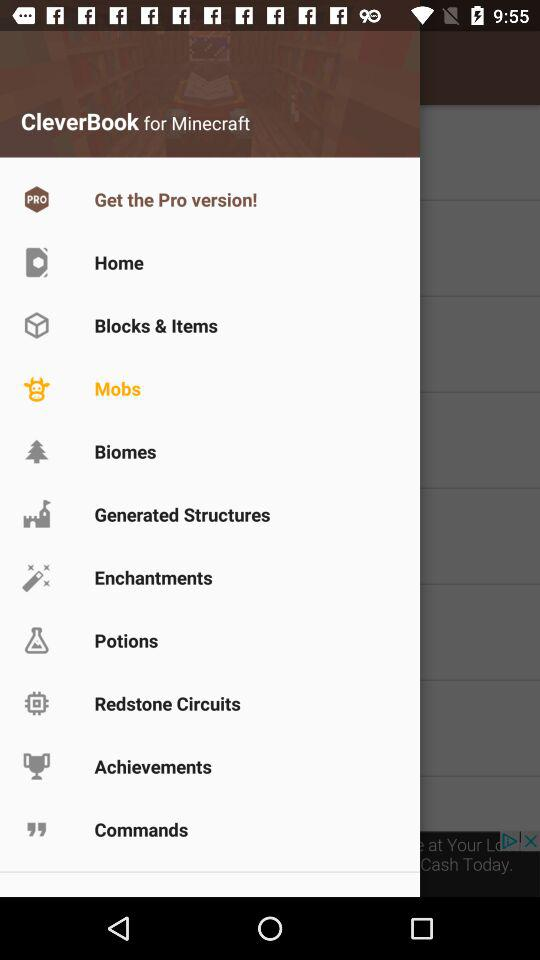What is the application name? The application name is "CleverBook for Minecraft". 